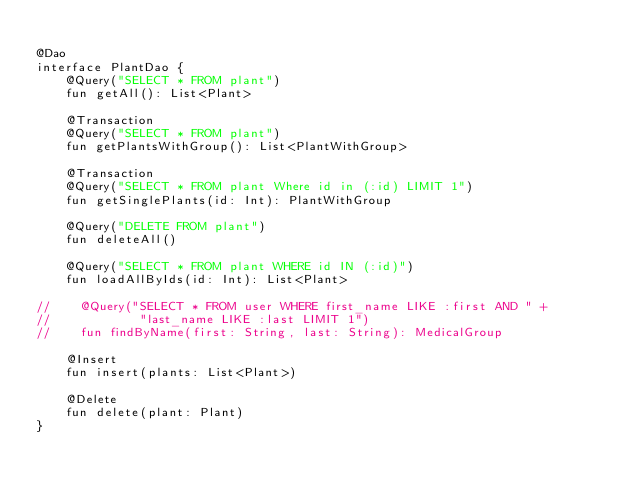<code> <loc_0><loc_0><loc_500><loc_500><_Kotlin_>
@Dao
interface PlantDao {
    @Query("SELECT * FROM plant")
    fun getAll(): List<Plant>

    @Transaction
    @Query("SELECT * FROM plant")
    fun getPlantsWithGroup(): List<PlantWithGroup>

    @Transaction
    @Query("SELECT * FROM plant Where id in (:id) LIMIT 1")
    fun getSinglePlants(id: Int): PlantWithGroup

    @Query("DELETE FROM plant")
    fun deleteAll()

    @Query("SELECT * FROM plant WHERE id IN (:id)")
    fun loadAllByIds(id: Int): List<Plant>

//    @Query("SELECT * FROM user WHERE first_name LIKE :first AND " +
//            "last_name LIKE :last LIMIT 1")
//    fun findByName(first: String, last: String): MedicalGroup

    @Insert
    fun insert(plants: List<Plant>)

    @Delete
    fun delete(plant: Plant)
}</code> 